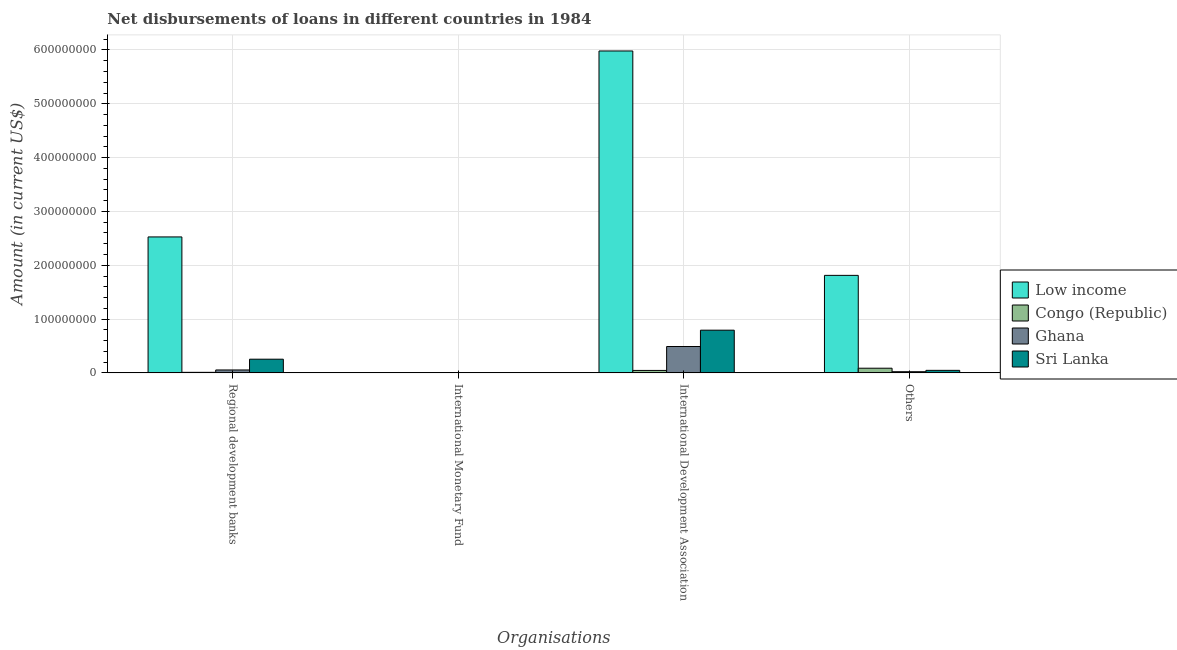How many different coloured bars are there?
Your answer should be very brief. 4. Are the number of bars on each tick of the X-axis equal?
Your answer should be compact. No. What is the label of the 4th group of bars from the left?
Make the answer very short. Others. What is the amount of loan disimbursed by international monetary fund in Low income?
Your answer should be compact. 0. Across all countries, what is the maximum amount of loan disimbursed by international development association?
Keep it short and to the point. 5.98e+08. Across all countries, what is the minimum amount of loan disimbursed by international monetary fund?
Your answer should be compact. 0. In which country was the amount of loan disimbursed by regional development banks maximum?
Give a very brief answer. Low income. What is the total amount of loan disimbursed by other organisations in the graph?
Provide a short and direct response. 1.97e+08. What is the difference between the amount of loan disimbursed by international development association in Congo (Republic) and that in Ghana?
Your answer should be compact. -4.45e+07. What is the difference between the amount of loan disimbursed by other organisations in Sri Lanka and the amount of loan disimbursed by international monetary fund in Ghana?
Give a very brief answer. 4.66e+06. What is the average amount of loan disimbursed by regional development banks per country?
Make the answer very short. 7.11e+07. What is the difference between the amount of loan disimbursed by other organisations and amount of loan disimbursed by international development association in Low income?
Keep it short and to the point. -4.17e+08. In how many countries, is the amount of loan disimbursed by regional development banks greater than 20000000 US$?
Your response must be concise. 2. What is the ratio of the amount of loan disimbursed by international development association in Congo (Republic) to that in Ghana?
Your answer should be very brief. 0.09. What is the difference between the highest and the second highest amount of loan disimbursed by regional development banks?
Make the answer very short. 2.27e+08. What is the difference between the highest and the lowest amount of loan disimbursed by regional development banks?
Provide a succinct answer. 2.52e+08. In how many countries, is the amount of loan disimbursed by other organisations greater than the average amount of loan disimbursed by other organisations taken over all countries?
Keep it short and to the point. 1. Is it the case that in every country, the sum of the amount of loan disimbursed by regional development banks and amount of loan disimbursed by international monetary fund is greater than the amount of loan disimbursed by international development association?
Make the answer very short. No. How many countries are there in the graph?
Give a very brief answer. 4. What is the difference between two consecutive major ticks on the Y-axis?
Keep it short and to the point. 1.00e+08. Are the values on the major ticks of Y-axis written in scientific E-notation?
Your answer should be compact. No. Does the graph contain any zero values?
Ensure brevity in your answer.  Yes. Does the graph contain grids?
Ensure brevity in your answer.  Yes. How many legend labels are there?
Offer a terse response. 4. How are the legend labels stacked?
Ensure brevity in your answer.  Vertical. What is the title of the graph?
Provide a short and direct response. Net disbursements of loans in different countries in 1984. What is the label or title of the X-axis?
Ensure brevity in your answer.  Organisations. What is the label or title of the Y-axis?
Ensure brevity in your answer.  Amount (in current US$). What is the Amount (in current US$) of Low income in Regional development banks?
Your answer should be compact. 2.53e+08. What is the Amount (in current US$) in Congo (Republic) in Regional development banks?
Offer a very short reply. 9.76e+05. What is the Amount (in current US$) of Ghana in Regional development banks?
Keep it short and to the point. 5.40e+06. What is the Amount (in current US$) of Sri Lanka in Regional development banks?
Provide a succinct answer. 2.54e+07. What is the Amount (in current US$) of Sri Lanka in International Monetary Fund?
Your answer should be very brief. 0. What is the Amount (in current US$) in Low income in International Development Association?
Provide a succinct answer. 5.98e+08. What is the Amount (in current US$) in Congo (Republic) in International Development Association?
Provide a short and direct response. 4.52e+06. What is the Amount (in current US$) in Ghana in International Development Association?
Ensure brevity in your answer.  4.90e+07. What is the Amount (in current US$) in Sri Lanka in International Development Association?
Your response must be concise. 7.93e+07. What is the Amount (in current US$) in Low income in Others?
Your answer should be compact. 1.81e+08. What is the Amount (in current US$) in Congo (Republic) in Others?
Your response must be concise. 8.66e+06. What is the Amount (in current US$) of Ghana in Others?
Keep it short and to the point. 2.14e+06. What is the Amount (in current US$) of Sri Lanka in Others?
Offer a very short reply. 4.66e+06. Across all Organisations, what is the maximum Amount (in current US$) in Low income?
Offer a very short reply. 5.98e+08. Across all Organisations, what is the maximum Amount (in current US$) in Congo (Republic)?
Offer a terse response. 8.66e+06. Across all Organisations, what is the maximum Amount (in current US$) of Ghana?
Your answer should be very brief. 4.90e+07. Across all Organisations, what is the maximum Amount (in current US$) of Sri Lanka?
Your answer should be compact. 7.93e+07. Across all Organisations, what is the minimum Amount (in current US$) of Low income?
Offer a terse response. 0. Across all Organisations, what is the minimum Amount (in current US$) of Congo (Republic)?
Give a very brief answer. 0. What is the total Amount (in current US$) of Low income in the graph?
Keep it short and to the point. 1.03e+09. What is the total Amount (in current US$) of Congo (Republic) in the graph?
Your response must be concise. 1.42e+07. What is the total Amount (in current US$) of Ghana in the graph?
Offer a terse response. 5.65e+07. What is the total Amount (in current US$) of Sri Lanka in the graph?
Provide a succinct answer. 1.09e+08. What is the difference between the Amount (in current US$) in Low income in Regional development banks and that in International Development Association?
Make the answer very short. -3.46e+08. What is the difference between the Amount (in current US$) of Congo (Republic) in Regional development banks and that in International Development Association?
Offer a very short reply. -3.54e+06. What is the difference between the Amount (in current US$) of Ghana in Regional development banks and that in International Development Association?
Offer a terse response. -4.36e+07. What is the difference between the Amount (in current US$) in Sri Lanka in Regional development banks and that in International Development Association?
Offer a terse response. -5.39e+07. What is the difference between the Amount (in current US$) of Low income in Regional development banks and that in Others?
Provide a succinct answer. 7.14e+07. What is the difference between the Amount (in current US$) of Congo (Republic) in Regional development banks and that in Others?
Your response must be concise. -7.69e+06. What is the difference between the Amount (in current US$) in Ghana in Regional development banks and that in Others?
Your answer should be compact. 3.26e+06. What is the difference between the Amount (in current US$) of Sri Lanka in Regional development banks and that in Others?
Ensure brevity in your answer.  2.08e+07. What is the difference between the Amount (in current US$) in Low income in International Development Association and that in Others?
Ensure brevity in your answer.  4.17e+08. What is the difference between the Amount (in current US$) of Congo (Republic) in International Development Association and that in Others?
Offer a very short reply. -4.14e+06. What is the difference between the Amount (in current US$) of Ghana in International Development Association and that in Others?
Offer a very short reply. 4.68e+07. What is the difference between the Amount (in current US$) in Sri Lanka in International Development Association and that in Others?
Provide a short and direct response. 7.47e+07. What is the difference between the Amount (in current US$) in Low income in Regional development banks and the Amount (in current US$) in Congo (Republic) in International Development Association?
Offer a very short reply. 2.48e+08. What is the difference between the Amount (in current US$) of Low income in Regional development banks and the Amount (in current US$) of Ghana in International Development Association?
Offer a very short reply. 2.04e+08. What is the difference between the Amount (in current US$) of Low income in Regional development banks and the Amount (in current US$) of Sri Lanka in International Development Association?
Provide a succinct answer. 1.73e+08. What is the difference between the Amount (in current US$) in Congo (Republic) in Regional development banks and the Amount (in current US$) in Ghana in International Development Association?
Keep it short and to the point. -4.80e+07. What is the difference between the Amount (in current US$) in Congo (Republic) in Regional development banks and the Amount (in current US$) in Sri Lanka in International Development Association?
Keep it short and to the point. -7.84e+07. What is the difference between the Amount (in current US$) of Ghana in Regional development banks and the Amount (in current US$) of Sri Lanka in International Development Association?
Offer a very short reply. -7.39e+07. What is the difference between the Amount (in current US$) of Low income in Regional development banks and the Amount (in current US$) of Congo (Republic) in Others?
Give a very brief answer. 2.44e+08. What is the difference between the Amount (in current US$) in Low income in Regional development banks and the Amount (in current US$) in Ghana in Others?
Ensure brevity in your answer.  2.50e+08. What is the difference between the Amount (in current US$) in Low income in Regional development banks and the Amount (in current US$) in Sri Lanka in Others?
Make the answer very short. 2.48e+08. What is the difference between the Amount (in current US$) in Congo (Republic) in Regional development banks and the Amount (in current US$) in Ghana in Others?
Ensure brevity in your answer.  -1.17e+06. What is the difference between the Amount (in current US$) of Congo (Republic) in Regional development banks and the Amount (in current US$) of Sri Lanka in Others?
Your answer should be compact. -3.69e+06. What is the difference between the Amount (in current US$) in Ghana in Regional development banks and the Amount (in current US$) in Sri Lanka in Others?
Offer a terse response. 7.42e+05. What is the difference between the Amount (in current US$) of Low income in International Development Association and the Amount (in current US$) of Congo (Republic) in Others?
Provide a succinct answer. 5.90e+08. What is the difference between the Amount (in current US$) in Low income in International Development Association and the Amount (in current US$) in Ghana in Others?
Provide a succinct answer. 5.96e+08. What is the difference between the Amount (in current US$) in Low income in International Development Association and the Amount (in current US$) in Sri Lanka in Others?
Offer a very short reply. 5.94e+08. What is the difference between the Amount (in current US$) in Congo (Republic) in International Development Association and the Amount (in current US$) in Ghana in Others?
Make the answer very short. 2.38e+06. What is the difference between the Amount (in current US$) in Congo (Republic) in International Development Association and the Amount (in current US$) in Sri Lanka in Others?
Your answer should be compact. -1.42e+05. What is the difference between the Amount (in current US$) of Ghana in International Development Association and the Amount (in current US$) of Sri Lanka in Others?
Your answer should be compact. 4.43e+07. What is the average Amount (in current US$) of Low income per Organisations?
Provide a short and direct response. 2.58e+08. What is the average Amount (in current US$) of Congo (Republic) per Organisations?
Keep it short and to the point. 3.54e+06. What is the average Amount (in current US$) in Ghana per Organisations?
Make the answer very short. 1.41e+07. What is the average Amount (in current US$) of Sri Lanka per Organisations?
Your answer should be compact. 2.74e+07. What is the difference between the Amount (in current US$) of Low income and Amount (in current US$) of Congo (Republic) in Regional development banks?
Offer a terse response. 2.52e+08. What is the difference between the Amount (in current US$) in Low income and Amount (in current US$) in Ghana in Regional development banks?
Provide a succinct answer. 2.47e+08. What is the difference between the Amount (in current US$) in Low income and Amount (in current US$) in Sri Lanka in Regional development banks?
Offer a very short reply. 2.27e+08. What is the difference between the Amount (in current US$) of Congo (Republic) and Amount (in current US$) of Ghana in Regional development banks?
Provide a short and direct response. -4.43e+06. What is the difference between the Amount (in current US$) in Congo (Republic) and Amount (in current US$) in Sri Lanka in Regional development banks?
Your answer should be compact. -2.44e+07. What is the difference between the Amount (in current US$) in Ghana and Amount (in current US$) in Sri Lanka in Regional development banks?
Your response must be concise. -2.00e+07. What is the difference between the Amount (in current US$) in Low income and Amount (in current US$) in Congo (Republic) in International Development Association?
Provide a short and direct response. 5.94e+08. What is the difference between the Amount (in current US$) in Low income and Amount (in current US$) in Ghana in International Development Association?
Ensure brevity in your answer.  5.49e+08. What is the difference between the Amount (in current US$) in Low income and Amount (in current US$) in Sri Lanka in International Development Association?
Make the answer very short. 5.19e+08. What is the difference between the Amount (in current US$) in Congo (Republic) and Amount (in current US$) in Ghana in International Development Association?
Your response must be concise. -4.45e+07. What is the difference between the Amount (in current US$) in Congo (Republic) and Amount (in current US$) in Sri Lanka in International Development Association?
Ensure brevity in your answer.  -7.48e+07. What is the difference between the Amount (in current US$) in Ghana and Amount (in current US$) in Sri Lanka in International Development Association?
Your answer should be very brief. -3.03e+07. What is the difference between the Amount (in current US$) of Low income and Amount (in current US$) of Congo (Republic) in Others?
Provide a short and direct response. 1.73e+08. What is the difference between the Amount (in current US$) of Low income and Amount (in current US$) of Ghana in Others?
Your answer should be very brief. 1.79e+08. What is the difference between the Amount (in current US$) in Low income and Amount (in current US$) in Sri Lanka in Others?
Keep it short and to the point. 1.77e+08. What is the difference between the Amount (in current US$) in Congo (Republic) and Amount (in current US$) in Ghana in Others?
Keep it short and to the point. 6.52e+06. What is the difference between the Amount (in current US$) of Congo (Republic) and Amount (in current US$) of Sri Lanka in Others?
Keep it short and to the point. 4.00e+06. What is the difference between the Amount (in current US$) in Ghana and Amount (in current US$) in Sri Lanka in Others?
Provide a short and direct response. -2.52e+06. What is the ratio of the Amount (in current US$) of Low income in Regional development banks to that in International Development Association?
Provide a succinct answer. 0.42. What is the ratio of the Amount (in current US$) in Congo (Republic) in Regional development banks to that in International Development Association?
Ensure brevity in your answer.  0.22. What is the ratio of the Amount (in current US$) in Ghana in Regional development banks to that in International Development Association?
Give a very brief answer. 0.11. What is the ratio of the Amount (in current US$) of Sri Lanka in Regional development banks to that in International Development Association?
Provide a succinct answer. 0.32. What is the ratio of the Amount (in current US$) in Low income in Regional development banks to that in Others?
Provide a succinct answer. 1.39. What is the ratio of the Amount (in current US$) in Congo (Republic) in Regional development banks to that in Others?
Provide a short and direct response. 0.11. What is the ratio of the Amount (in current US$) in Ghana in Regional development banks to that in Others?
Offer a very short reply. 2.52. What is the ratio of the Amount (in current US$) in Sri Lanka in Regional development banks to that in Others?
Your answer should be very brief. 5.45. What is the ratio of the Amount (in current US$) of Low income in International Development Association to that in Others?
Your answer should be compact. 3.3. What is the ratio of the Amount (in current US$) in Congo (Republic) in International Development Association to that in Others?
Offer a terse response. 0.52. What is the ratio of the Amount (in current US$) in Ghana in International Development Association to that in Others?
Your answer should be very brief. 22.84. What is the ratio of the Amount (in current US$) of Sri Lanka in International Development Association to that in Others?
Your answer should be very brief. 17.01. What is the difference between the highest and the second highest Amount (in current US$) of Low income?
Your answer should be very brief. 3.46e+08. What is the difference between the highest and the second highest Amount (in current US$) of Congo (Republic)?
Offer a terse response. 4.14e+06. What is the difference between the highest and the second highest Amount (in current US$) of Ghana?
Provide a succinct answer. 4.36e+07. What is the difference between the highest and the second highest Amount (in current US$) of Sri Lanka?
Ensure brevity in your answer.  5.39e+07. What is the difference between the highest and the lowest Amount (in current US$) in Low income?
Your answer should be compact. 5.98e+08. What is the difference between the highest and the lowest Amount (in current US$) in Congo (Republic)?
Give a very brief answer. 8.66e+06. What is the difference between the highest and the lowest Amount (in current US$) in Ghana?
Your response must be concise. 4.90e+07. What is the difference between the highest and the lowest Amount (in current US$) in Sri Lanka?
Provide a succinct answer. 7.93e+07. 